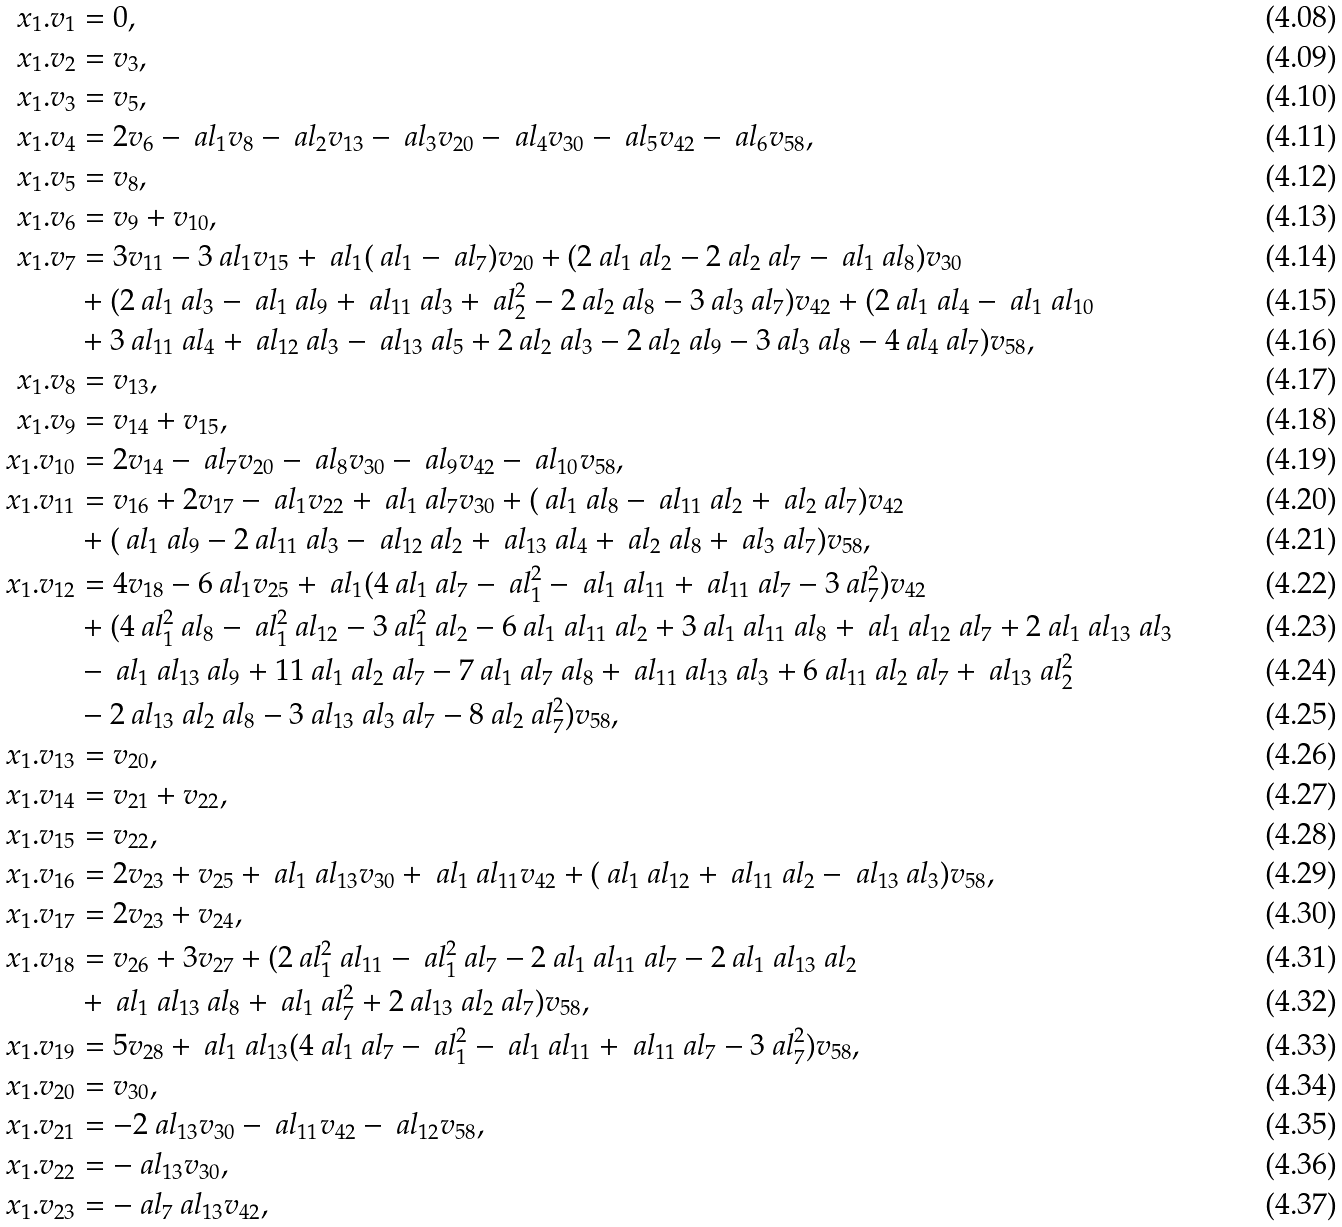<formula> <loc_0><loc_0><loc_500><loc_500>x _ { 1 } . v _ { 1 } & = 0 , \\ x _ { 1 } . v _ { 2 } & = v _ { 3 } , \\ x _ { 1 } . v _ { 3 } & = v _ { 5 } , \\ x _ { 1 } . v _ { 4 } & = 2 v _ { 6 } - \ a l _ { 1 } v _ { 8 } - \ a l _ { 2 } v _ { 1 3 } - \ a l _ { 3 } v _ { 2 0 } - \ a l _ { 4 } v _ { 3 0 } - \ a l _ { 5 } v _ { 4 2 } - \ a l _ { 6 } v _ { 5 8 } , \\ x _ { 1 } . v _ { 5 } & = v _ { 8 } , \\ x _ { 1 } . v _ { 6 } & = v _ { 9 } + v _ { 1 0 } , \\ x _ { 1 } . v _ { 7 } & = 3 v _ { 1 1 } - 3 \ a l _ { 1 } v _ { 1 5 } + \ a l _ { 1 } ( \ a l _ { 1 } - \ a l _ { 7 } ) v _ { 2 0 } + ( 2 \ a l _ { 1 } \ a l _ { 2 } - 2 \ a l _ { 2 } \ a l _ { 7 } - \ a l _ { 1 } \ a l _ { 8 } ) v _ { 3 0 } \\ & + ( 2 \ a l _ { 1 } \ a l _ { 3 } - \ a l _ { 1 } \ a l _ { 9 } + \ a l _ { 1 1 } \ a l _ { 3 } + \ a l _ { 2 } ^ { 2 } - 2 \ a l _ { 2 } \ a l _ { 8 } - 3 \ a l _ { 3 } \ a l _ { 7 } ) v _ { 4 2 } + ( 2 \ a l _ { 1 } \ a l _ { 4 } - \ a l _ { 1 } \ a l _ { 1 0 } \\ & + 3 \ a l _ { 1 1 } \ a l _ { 4 } + \ a l _ { 1 2 } \ a l _ { 3 } - \ a l _ { 1 3 } \ a l _ { 5 } + 2 \ a l _ { 2 } \ a l _ { 3 } - 2 \ a l _ { 2 } \ a l _ { 9 } - 3 \ a l _ { 3 } \ a l _ { 8 } - 4 \ a l _ { 4 } \ a l _ { 7 } ) v _ { 5 8 } , \\ x _ { 1 } . v _ { 8 } & = v _ { 1 3 } , \\ x _ { 1 } . v _ { 9 } & = v _ { 1 4 } + v _ { 1 5 } , \\ x _ { 1 } . v _ { 1 0 } & = 2 v _ { 1 4 } - \ a l _ { 7 } v _ { 2 0 } - \ a l _ { 8 } v _ { 3 0 } - \ a l _ { 9 } v _ { 4 2 } - \ a l _ { 1 0 } v _ { 5 8 } , \\ x _ { 1 } . v _ { 1 1 } & = v _ { 1 6 } + 2 v _ { 1 7 } - \ a l _ { 1 } v _ { 2 2 } + \ a l _ { 1 } \ a l _ { 7 } v _ { 3 0 } + ( \ a l _ { 1 } \ a l _ { 8 } - \ a l _ { 1 1 } \ a l _ { 2 } + \ a l _ { 2 } \ a l _ { 7 } ) v _ { 4 2 } \\ & + ( \ a l _ { 1 } \ a l _ { 9 } - 2 \ a l _ { 1 1 } \ a l _ { 3 } - \ a l _ { 1 2 } \ a l _ { 2 } + \ a l _ { 1 3 } \ a l _ { 4 } + \ a l _ { 2 } \ a l _ { 8 } + \ a l _ { 3 } \ a l _ { 7 } ) v _ { 5 8 } , \\ x _ { 1 } . v _ { 1 2 } & = 4 v _ { 1 8 } - 6 \ a l _ { 1 } v _ { 2 5 } + \ a l _ { 1 } ( 4 \ a l _ { 1 } \ a l _ { 7 } - \ a l _ { 1 } ^ { 2 } - \ a l _ { 1 } \ a l _ { 1 1 } + \ a l _ { 1 1 } \ a l _ { 7 } - 3 \ a l _ { 7 } ^ { 2 } ) v _ { 4 2 } \\ & + ( 4 \ a l _ { 1 } ^ { 2 } \ a l _ { 8 } - \ a l _ { 1 } ^ { 2 } \ a l _ { 1 2 } - 3 \ a l _ { 1 } ^ { 2 } \ a l _ { 2 } - 6 \ a l _ { 1 } \ a l _ { 1 1 } \ a l _ { 2 } + 3 \ a l _ { 1 } \ a l _ { 1 1 } \ a l _ { 8 } + \ a l _ { 1 } \ a l _ { 1 2 } \ a l _ { 7 } + 2 \ a l _ { 1 } \ a l _ { 1 3 } \ a l _ { 3 } \\ & - \ a l _ { 1 } \ a l _ { 1 3 } \ a l _ { 9 } + 1 1 \ a l _ { 1 } \ a l _ { 2 } \ a l _ { 7 } - 7 \ a l _ { 1 } \ a l _ { 7 } \ a l _ { 8 } + \ a l _ { 1 1 } \ a l _ { 1 3 } \ a l _ { 3 } + 6 \ a l _ { 1 1 } \ a l _ { 2 } \ a l _ { 7 } + \ a l _ { 1 3 } \ a l _ { 2 } ^ { 2 } \\ & - 2 \ a l _ { 1 3 } \ a l _ { 2 } \ a l _ { 8 } - 3 \ a l _ { 1 3 } \ a l _ { 3 } \ a l _ { 7 } - 8 \ a l _ { 2 } \ a l _ { 7 } ^ { 2 } ) v _ { 5 8 } , \\ x _ { 1 } . v _ { 1 3 } & = v _ { 2 0 } , \\ x _ { 1 } . v _ { 1 4 } & = v _ { 2 1 } + v _ { 2 2 } , \\ x _ { 1 } . v _ { 1 5 } & = v _ { 2 2 } , \\ x _ { 1 } . v _ { 1 6 } & = 2 v _ { 2 3 } + v _ { 2 5 } + \ a l _ { 1 } \ a l _ { 1 3 } v _ { 3 0 } + \ a l _ { 1 } \ a l _ { 1 1 } v _ { 4 2 } + ( \ a l _ { 1 } \ a l _ { 1 2 } + \ a l _ { 1 1 } \ a l _ { 2 } - \ a l _ { 1 3 } \ a l _ { 3 } ) v _ { 5 8 } , \\ x _ { 1 } . v _ { 1 7 } & = 2 v _ { 2 3 } + v _ { 2 4 } , \\ x _ { 1 } . v _ { 1 8 } & = v _ { 2 6 } + 3 v _ { 2 7 } + ( 2 \ a l _ { 1 } ^ { 2 } \ a l _ { 1 1 } - \ a l _ { 1 } ^ { 2 } \ a l _ { 7 } - 2 \ a l _ { 1 } \ a l _ { 1 1 } \ a l _ { 7 } - 2 \ a l _ { 1 } \ a l _ { 1 3 } \ a l _ { 2 } \\ & + \ a l _ { 1 } \ a l _ { 1 3 } \ a l _ { 8 } + \ a l _ { 1 } \ a l _ { 7 } ^ { 2 } + 2 \ a l _ { 1 3 } \ a l _ { 2 } \ a l _ { 7 } ) v _ { 5 8 } , \\ x _ { 1 } . v _ { 1 9 } & = 5 v _ { 2 8 } + \ a l _ { 1 } \ a l _ { 1 3 } ( 4 \ a l _ { 1 } \ a l _ { 7 } - \ a l _ { 1 } ^ { 2 } - \ a l _ { 1 } \ a l _ { 1 1 } + \ a l _ { 1 1 } \ a l _ { 7 } - 3 \ a l _ { 7 } ^ { 2 } ) v _ { 5 8 } , \\ x _ { 1 } . v _ { 2 0 } & = v _ { 3 0 } , \\ x _ { 1 } . v _ { 2 1 } & = - 2 \ a l _ { 1 3 } v _ { 3 0 } - \ a l _ { 1 1 } v _ { 4 2 } - \ a l _ { 1 2 } v _ { 5 8 } , \\ x _ { 1 } . v _ { 2 2 } & = - \ a l _ { 1 3 } v _ { 3 0 } , \\ x _ { 1 } . v _ { 2 3 } & = - \ a l _ { 7 } \ a l _ { 1 3 } v _ { 4 2 } ,</formula> 